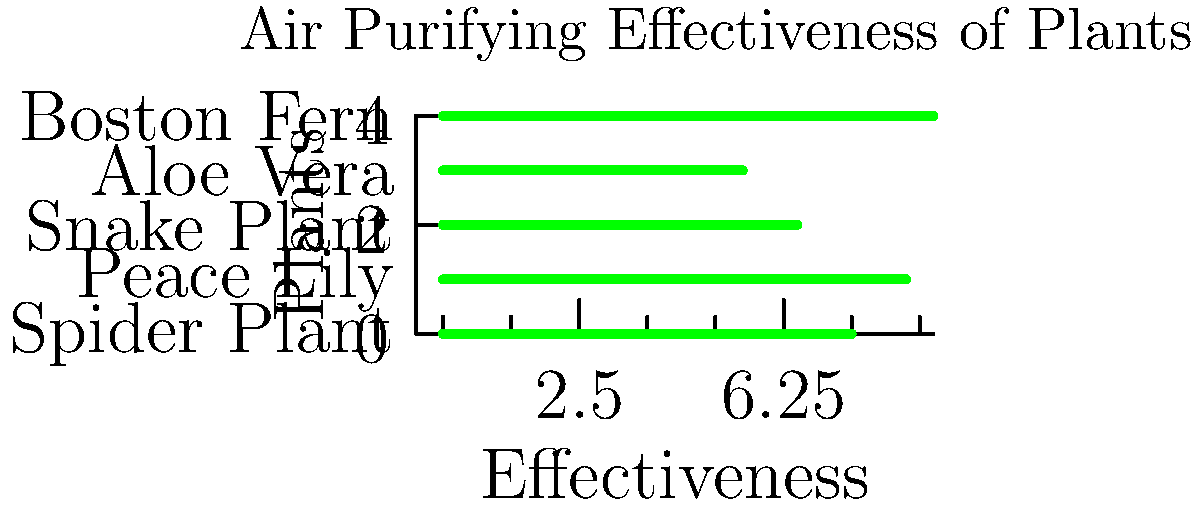Based on the graph showing the air purifying effectiveness of various plants, which plant would be most beneficial for someone with severe seasonal allergies to have in their home? To determine the most beneficial plant for someone with severe seasonal allergies, we need to analyze the air purifying effectiveness of each plant shown in the graph:

1. Spider Plant: Effectiveness score of 7.5
2. Peace Lily: Effectiveness score of 8.5
3. Snake Plant: Effectiveness score of 6.5
4. Aloe Vera: Effectiveness score of 5.5
5. Boston Fern: Effectiveness score of 9.0

The plant with the highest effectiveness score would be most beneficial for purifying the air and potentially reducing allergens. In this case, the Boston Fern has the highest score of 9.0 on the effectiveness scale.

Higher air purifying effectiveness means the plant is more efficient at removing pollutants and improving air quality, which can help alleviate allergy symptoms by reducing airborne allergens and irritants.

Therefore, the Boston Fern would be the most beneficial plant for someone with severe seasonal allergies to have in their home.
Answer: Boston Fern 